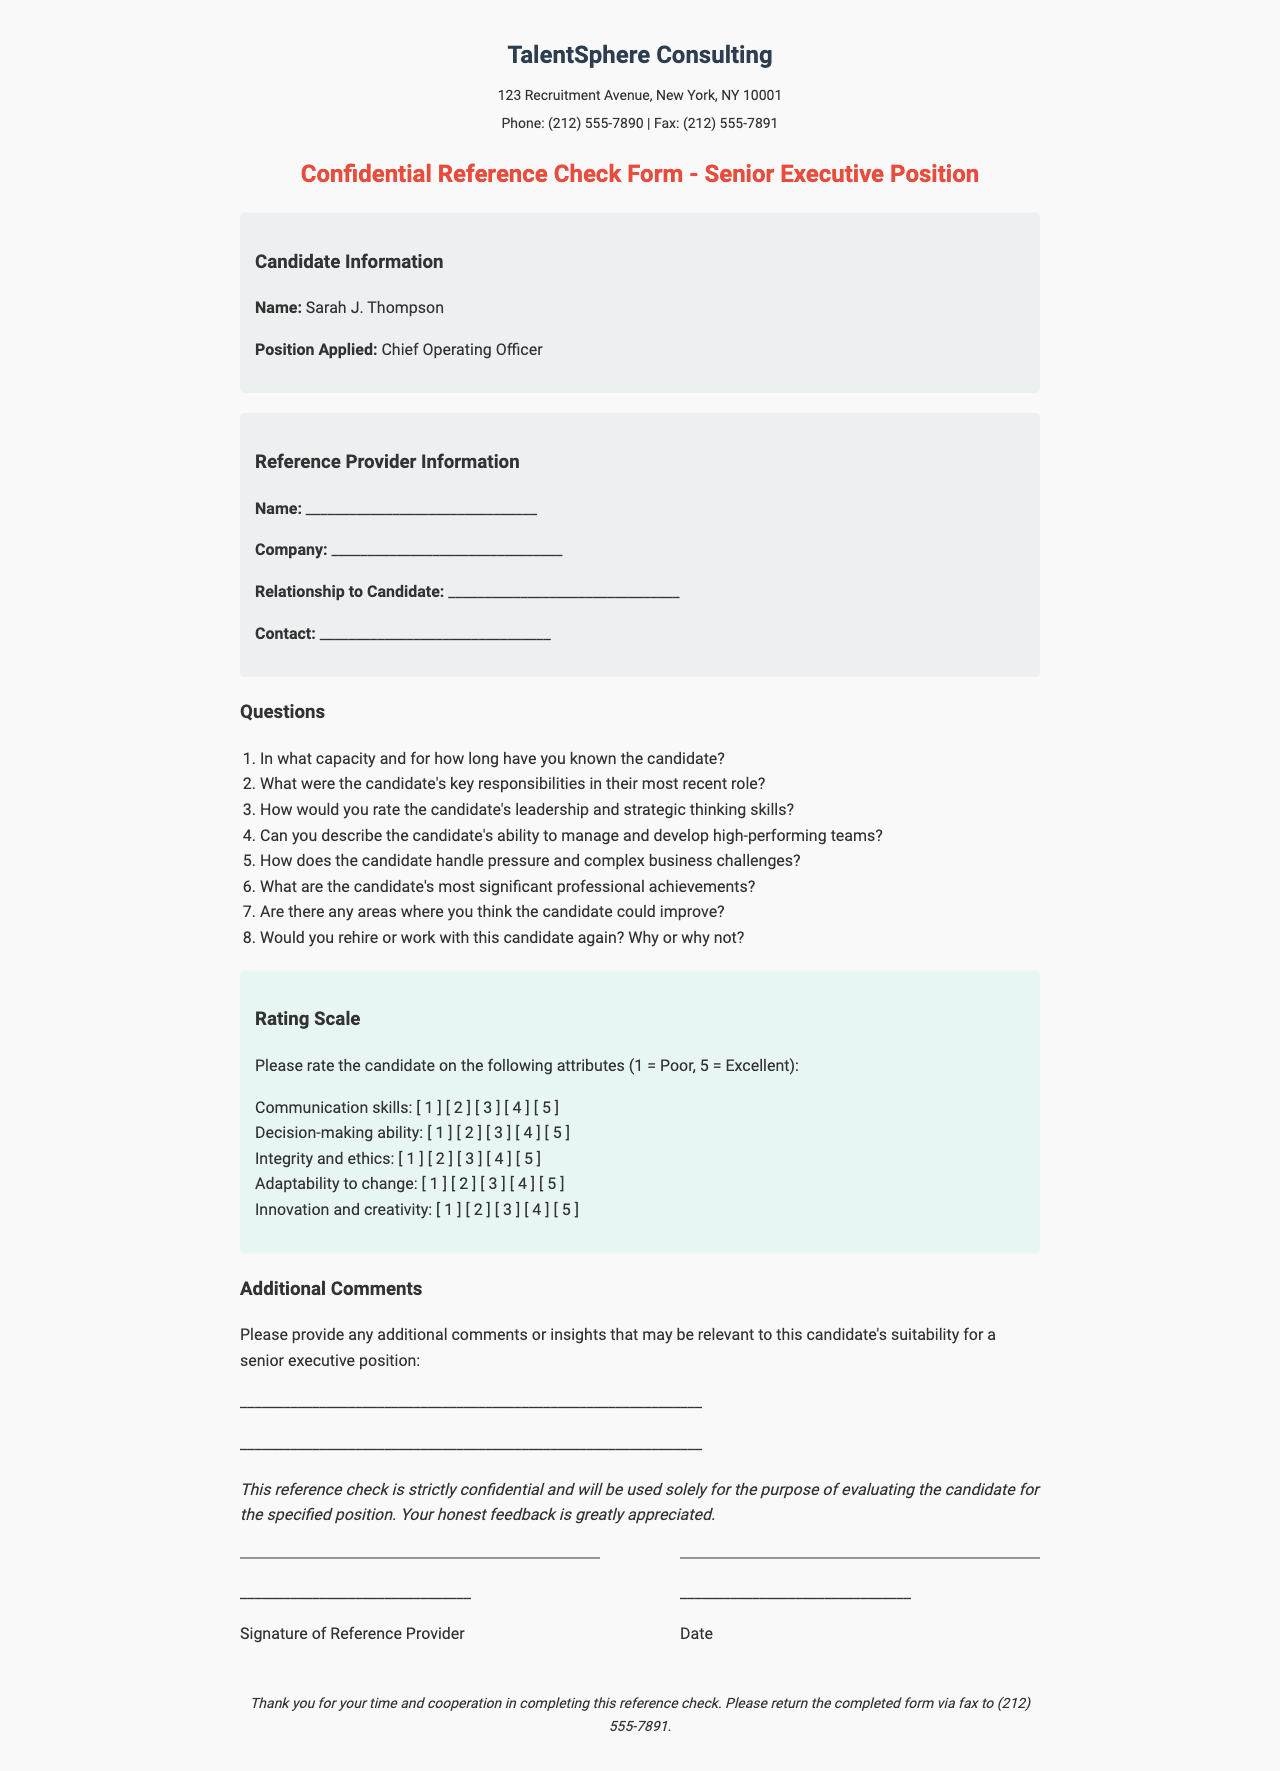What is the name of the candidate? The name of the candidate is provided in the candidate information section of the document.
Answer: Sarah J. Thompson What position is the candidate applying for? The position applied for is specified in the candidate information section.
Answer: Chief Operating Officer What is the fax number for TalentSphere Consulting? The fax number can be found in the header section of the document.
Answer: (212) 555-7891 How many questions are listed for the reference provider? The total number of questions can be counted in the questions section of the document.
Answer: 8 What is the scale used for rating the candidate's attributes? The rating scale is described in the rating scale section where ratings from 1 to 5 are mentioned.
Answer: 1 to 5 What is one of the attributes the candidate is rated on? The attributes for rating are outlined in the rating scale section.
Answer: Communication skills What type of document is this? The purpose of the document is specified in the title and introduction.
Answer: Confidential Reference Check Form What should the reference provider do after completing the form? The footer includes instructions on what to do with the completed form.
Answer: Return via fax to (212) 555-7891 